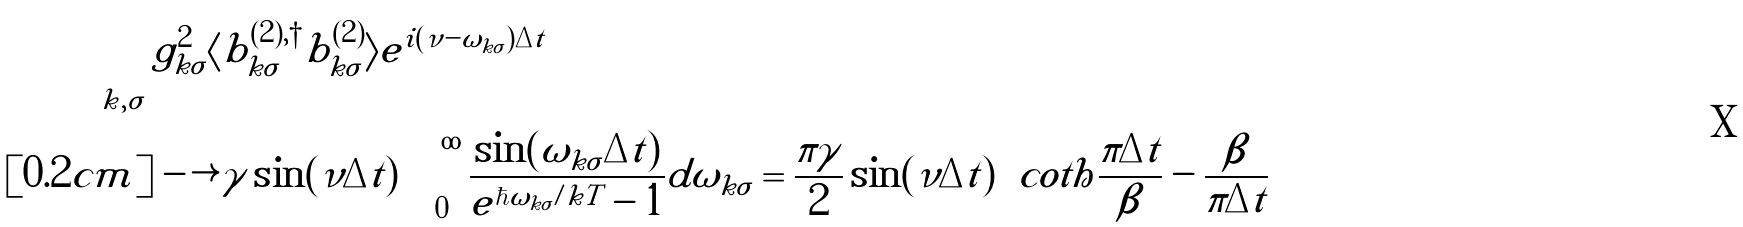Convert formula to latex. <formula><loc_0><loc_0><loc_500><loc_500>\sum _ { k , \sigma } & g _ { k \sigma } ^ { 2 } \langle b _ { k \sigma } ^ { ( 2 ) , \dagger } b _ { k \sigma } ^ { ( 2 ) } \rangle e ^ { i ( \nu - \omega _ { k \sigma } ) \Delta t } \\ [ 0 . 2 c m ] & \longrightarrow \gamma \sin ( \nu \Delta t ) \int _ { 0 } ^ { \infty } \frac { \sin ( \omega _ { k \sigma } \Delta t ) } { e ^ { \hbar { \omega } _ { k \sigma } / k T } - 1 } d \omega _ { k \sigma } = \frac { \pi \gamma } { 2 } \sin ( \nu \Delta t ) \left ( c o t h \frac { \pi \Delta t } { \beta } - \frac { \beta } { \pi \Delta t } \right )</formula> 